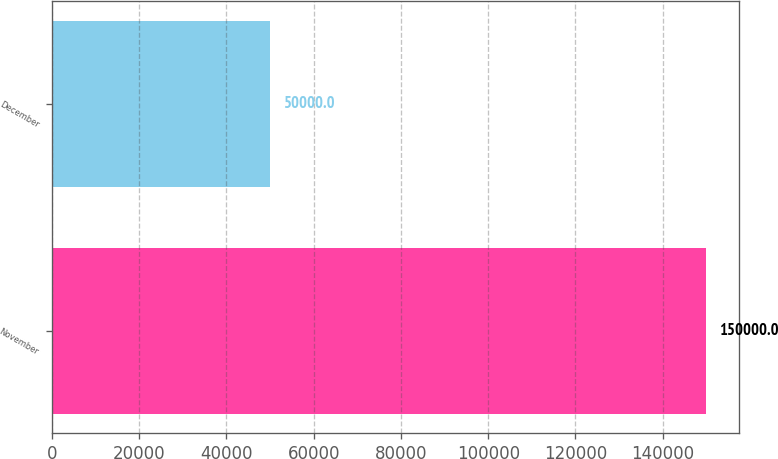Convert chart. <chart><loc_0><loc_0><loc_500><loc_500><bar_chart><fcel>November<fcel>December<nl><fcel>150000<fcel>50000<nl></chart> 